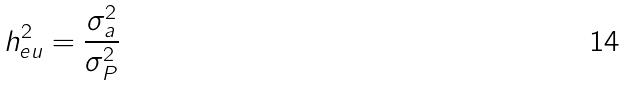<formula> <loc_0><loc_0><loc_500><loc_500>h _ { e u } ^ { 2 } = \frac { \sigma _ { a } ^ { 2 } } { \sigma _ { P } ^ { 2 } }</formula> 